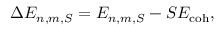Convert formula to latex. <formula><loc_0><loc_0><loc_500><loc_500>\Delta E _ { n , m , S } = E _ { n , m , S } - S E _ { c o h } ,</formula> 